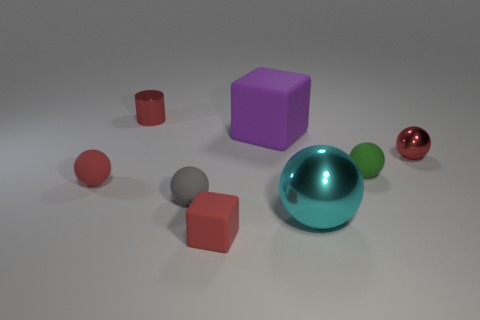How many blocks are either small gray metal things or gray matte things?
Give a very brief answer. 0. What is the shape of the big metallic object?
Give a very brief answer. Sphere. Are there any metallic balls in front of the green ball?
Make the answer very short. Yes. Does the small gray thing have the same material as the small red object on the left side of the cylinder?
Keep it short and to the point. Yes. There is a red metallic object in front of the small red metal cylinder; is it the same shape as the purple matte thing?
Ensure brevity in your answer.  No. How many small cylinders have the same material as the cyan thing?
Offer a terse response. 1. How many objects are either red metallic objects that are on the right side of the large matte thing or big metal balls?
Make the answer very short. 2. How big is the cyan object?
Make the answer very short. Large. The small red ball on the left side of the tiny green matte ball in front of the purple thing is made of what material?
Your response must be concise. Rubber. There is a red sphere that is left of the purple rubber block; is it the same size as the green rubber object?
Offer a very short reply. Yes. 